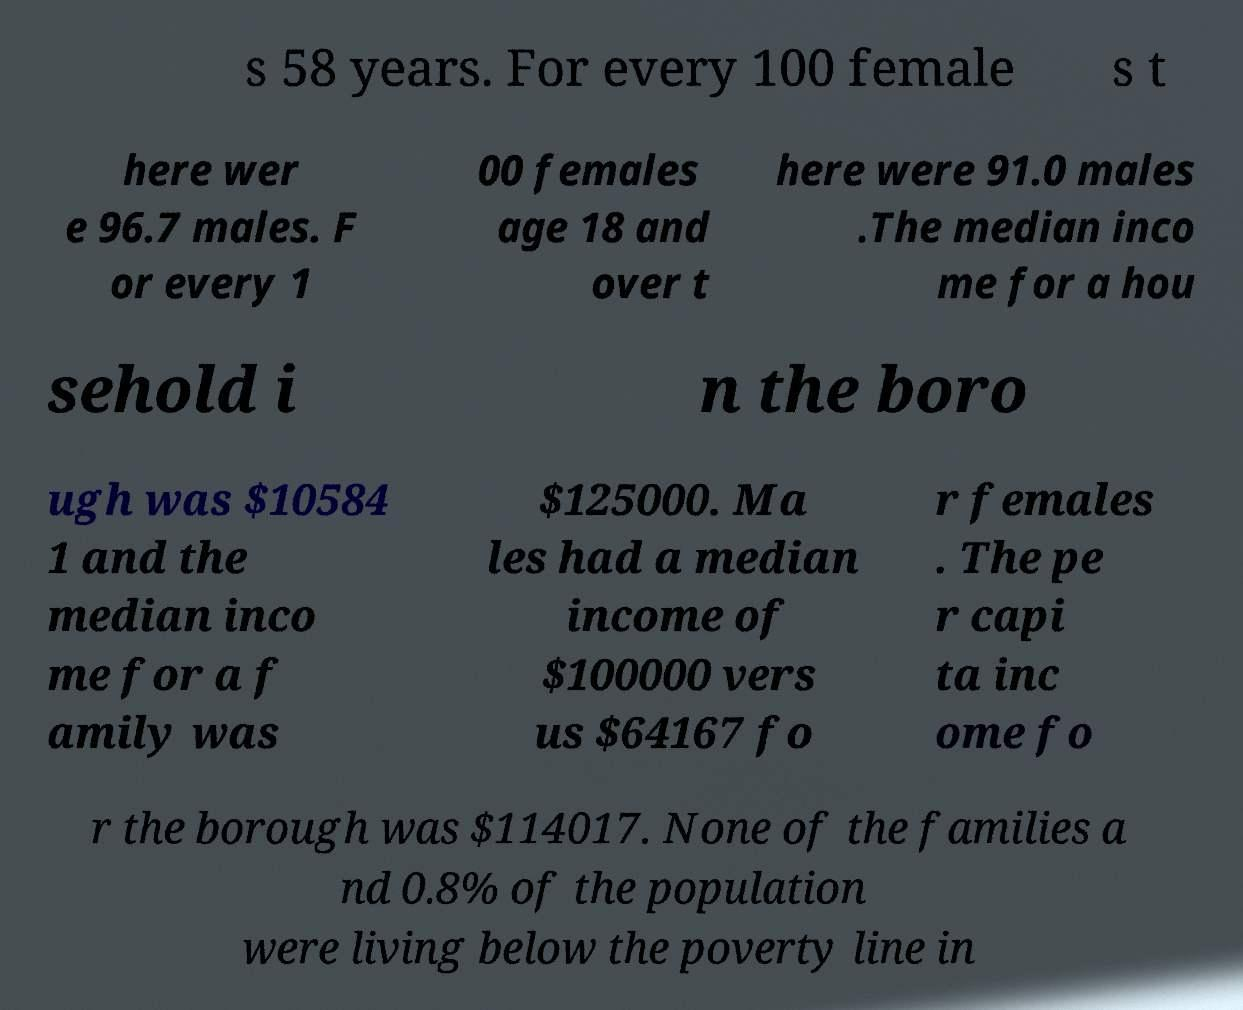What messages or text are displayed in this image? I need them in a readable, typed format. s 58 years. For every 100 female s t here wer e 96.7 males. F or every 1 00 females age 18 and over t here were 91.0 males .The median inco me for a hou sehold i n the boro ugh was $10584 1 and the median inco me for a f amily was $125000. Ma les had a median income of $100000 vers us $64167 fo r females . The pe r capi ta inc ome fo r the borough was $114017. None of the families a nd 0.8% of the population were living below the poverty line in 